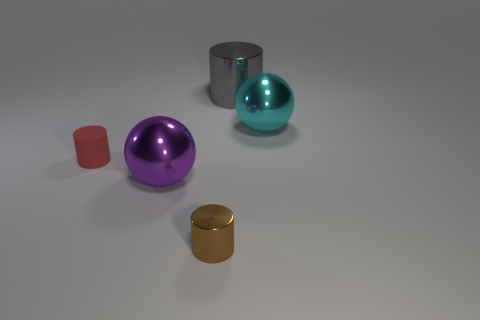What is the color of the metallic object that is both on the left side of the large cylinder and right of the large purple ball?
Offer a very short reply. Brown. How many balls are tiny matte things or big cyan metal objects?
Your response must be concise. 1. Are there fewer tiny metallic things that are in front of the brown thing than small blue objects?
Give a very brief answer. No. What is the shape of the brown object that is the same material as the gray thing?
Give a very brief answer. Cylinder. What number of things are large blue metal spheres or shiny objects?
Offer a very short reply. 4. There is a big ball that is left of the small object right of the purple thing; what is its material?
Give a very brief answer. Metal. Are there any brown cylinders made of the same material as the cyan sphere?
Keep it short and to the point. Yes. What is the shape of the big gray metal thing behind the big sphere in front of the large metal object to the right of the big gray shiny cylinder?
Give a very brief answer. Cylinder. What material is the large gray object?
Your response must be concise. Metal. What color is the large cylinder that is made of the same material as the big purple thing?
Your answer should be very brief. Gray. 